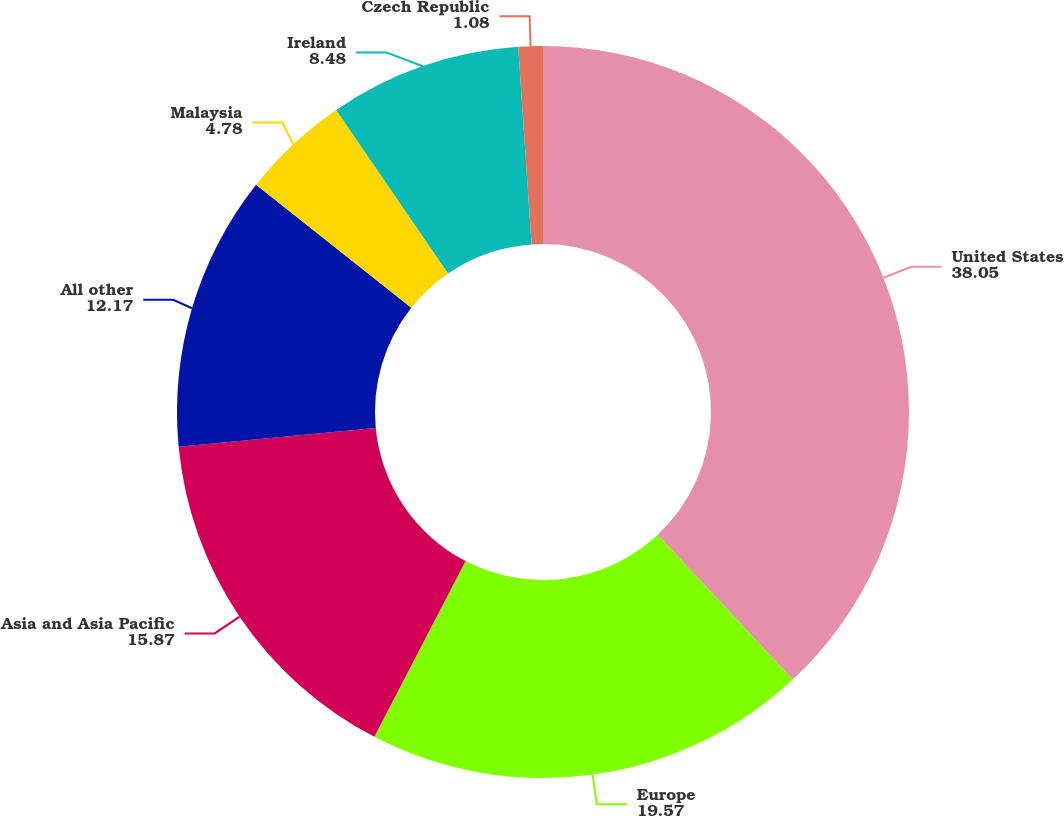Convert chart. <chart><loc_0><loc_0><loc_500><loc_500><pie_chart><fcel>United States<fcel>Europe<fcel>Asia and Asia Pacific<fcel>All other<fcel>Malaysia<fcel>Ireland<fcel>Czech Republic<nl><fcel>38.05%<fcel>19.57%<fcel>15.87%<fcel>12.17%<fcel>4.78%<fcel>8.48%<fcel>1.08%<nl></chart> 